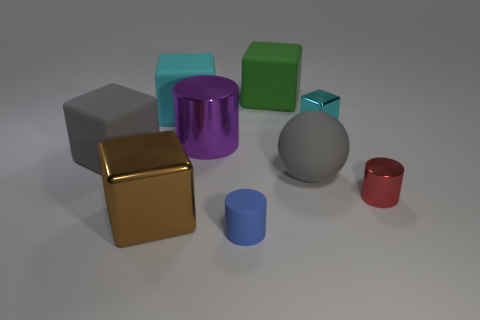There is a blue cylinder that is the same size as the red shiny cylinder; what is its material?
Your answer should be compact. Rubber. Do the shiny cylinder that is right of the tiny cyan shiny cube and the matte block that is to the right of the purple metallic cylinder have the same size?
Offer a very short reply. No. What number of things are rubber balls or objects that are behind the gray rubber ball?
Your response must be concise. 6. Are there any yellow matte things of the same shape as the green thing?
Keep it short and to the point. No. How big is the rubber block in front of the metallic block that is behind the large brown shiny block?
Offer a terse response. Large. Does the large metallic cylinder have the same color as the large matte ball?
Keep it short and to the point. No. How many shiny objects are either big cylinders or tiny cylinders?
Provide a succinct answer. 2. How many brown objects are there?
Give a very brief answer. 1. Does the gray block that is left of the green thing have the same material as the cylinder that is right of the green cube?
Provide a succinct answer. No. There is a small shiny object that is the same shape as the tiny blue matte thing; what is its color?
Your answer should be compact. Red. 